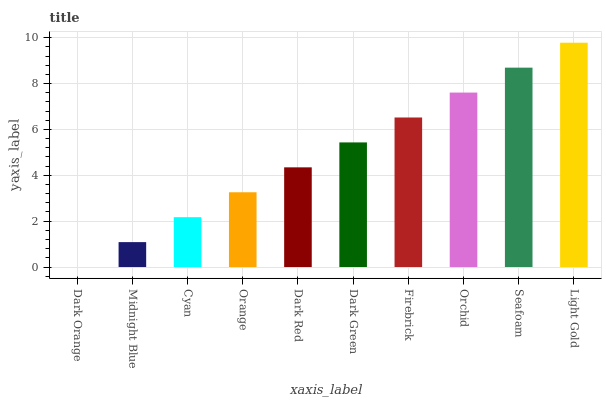Is Midnight Blue the minimum?
Answer yes or no. No. Is Midnight Blue the maximum?
Answer yes or no. No. Is Midnight Blue greater than Dark Orange?
Answer yes or no. Yes. Is Dark Orange less than Midnight Blue?
Answer yes or no. Yes. Is Dark Orange greater than Midnight Blue?
Answer yes or no. No. Is Midnight Blue less than Dark Orange?
Answer yes or no. No. Is Dark Green the high median?
Answer yes or no. Yes. Is Dark Red the low median?
Answer yes or no. Yes. Is Cyan the high median?
Answer yes or no. No. Is Dark Orange the low median?
Answer yes or no. No. 